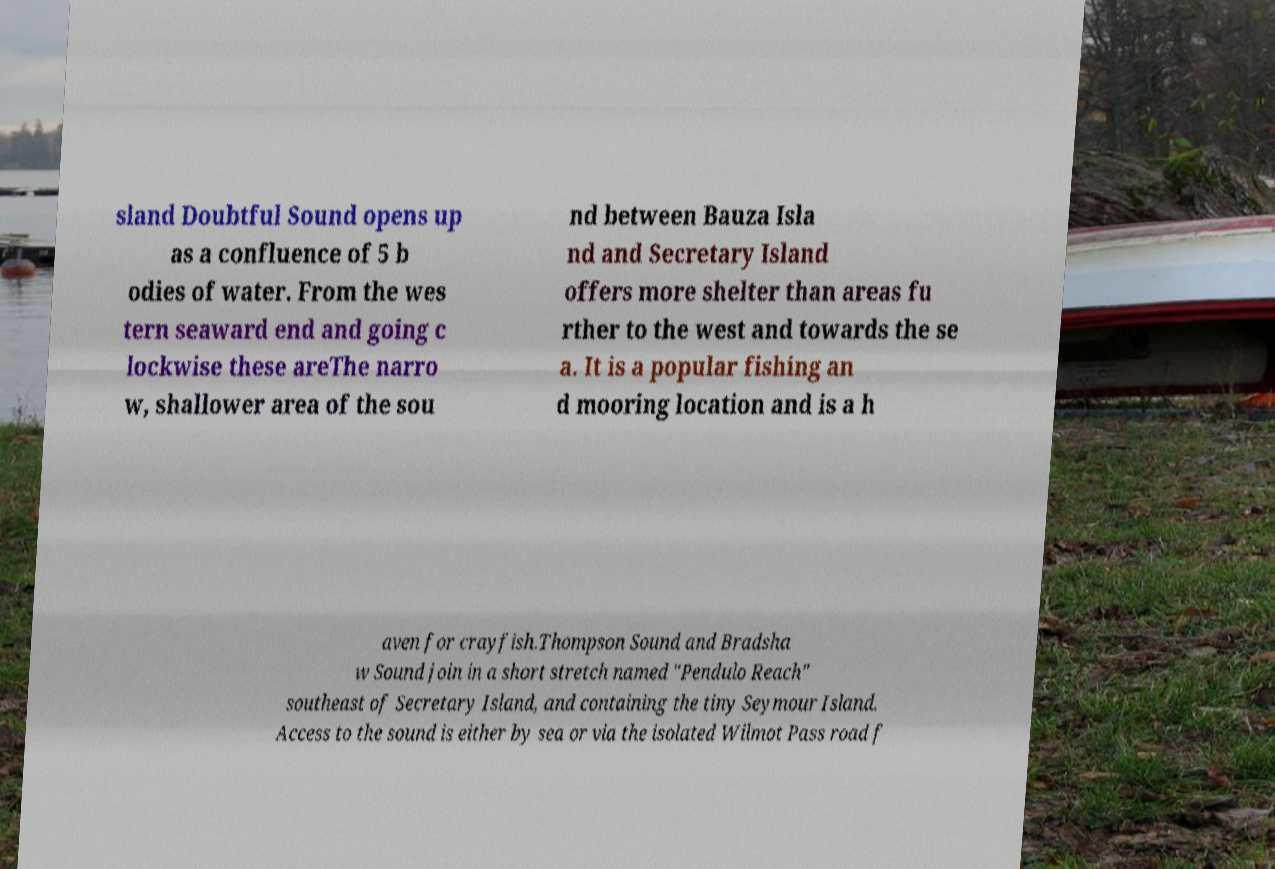What messages or text are displayed in this image? I need them in a readable, typed format. sland Doubtful Sound opens up as a confluence of 5 b odies of water. From the wes tern seaward end and going c lockwise these areThe narro w, shallower area of the sou nd between Bauza Isla nd and Secretary Island offers more shelter than areas fu rther to the west and towards the se a. It is a popular fishing an d mooring location and is a h aven for crayfish.Thompson Sound and Bradsha w Sound join in a short stretch named "Pendulo Reach" southeast of Secretary Island, and containing the tiny Seymour Island. Access to the sound is either by sea or via the isolated Wilmot Pass road f 